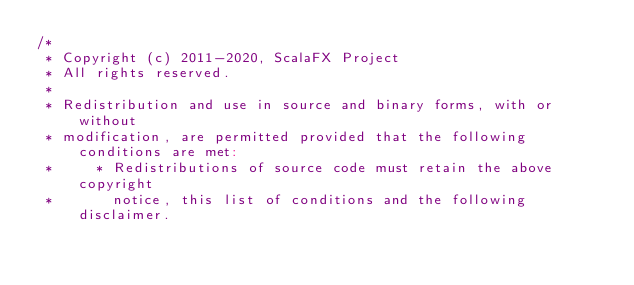Convert code to text. <code><loc_0><loc_0><loc_500><loc_500><_Scala_>/*
 * Copyright (c) 2011-2020, ScalaFX Project
 * All rights reserved.
 *
 * Redistribution and use in source and binary forms, with or without
 * modification, are permitted provided that the following conditions are met:
 *     * Redistributions of source code must retain the above copyright
 *       notice, this list of conditions and the following disclaimer.</code> 